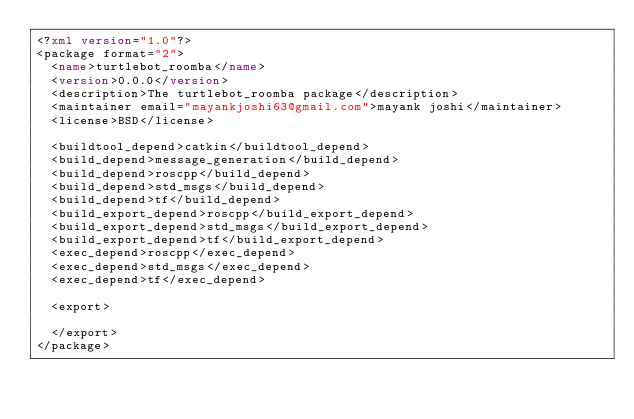Convert code to text. <code><loc_0><loc_0><loc_500><loc_500><_XML_><?xml version="1.0"?>
<package format="2">
  <name>turtlebot_roomba</name>
  <version>0.0.0</version>
  <description>The turtlebot_roomba package</description>
  <maintainer email="mayankjoshi63@gmail.com">mayank joshi</maintainer>
  <license>BSD</license>

  <buildtool_depend>catkin</buildtool_depend>
  <build_depend>message_generation</build_depend>
  <build_depend>roscpp</build_depend>
  <build_depend>std_msgs</build_depend>
  <build_depend>tf</build_depend>
  <build_export_depend>roscpp</build_export_depend>
  <build_export_depend>std_msgs</build_export_depend>
  <build_export_depend>tf</build_export_depend>
  <exec_depend>roscpp</exec_depend>
  <exec_depend>std_msgs</exec_depend>
  <exec_depend>tf</exec_depend>

  <export>

  </export>
</package>
</code> 